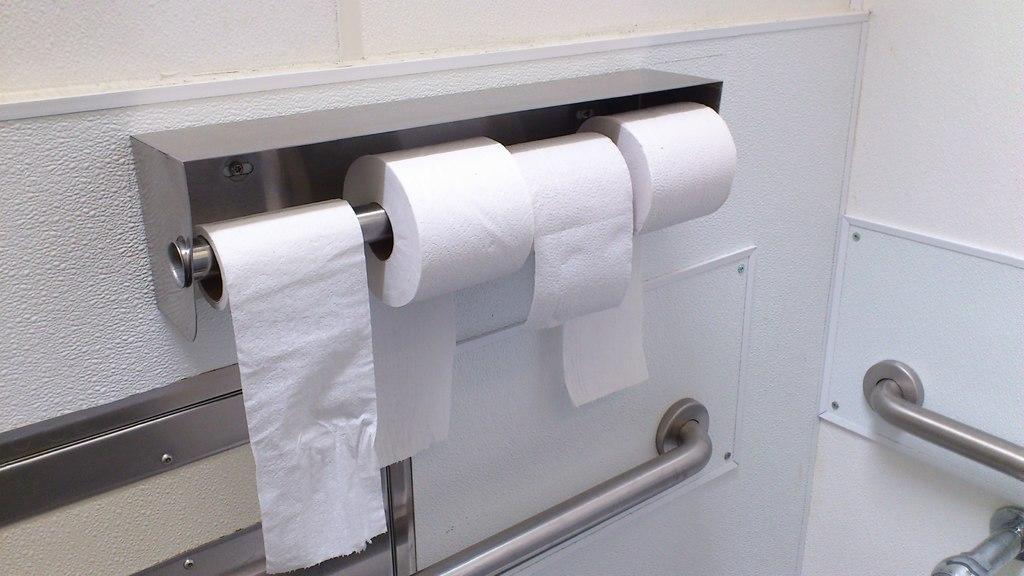How many tissue rolls are present in the image? There are four tissue rolls in the image. What is supporting the tissue rolls in the image? There are two rods at the bottom of the image supporting the tissue rolls. What can be seen in the background of the image? There is a wall visible in the background of the image. What type of paste or glue is being used to hold the tissue rolls together in the image? There is no paste or glue visible in the image, and the tissue rolls are not being held together; they are simply resting on the rods. 